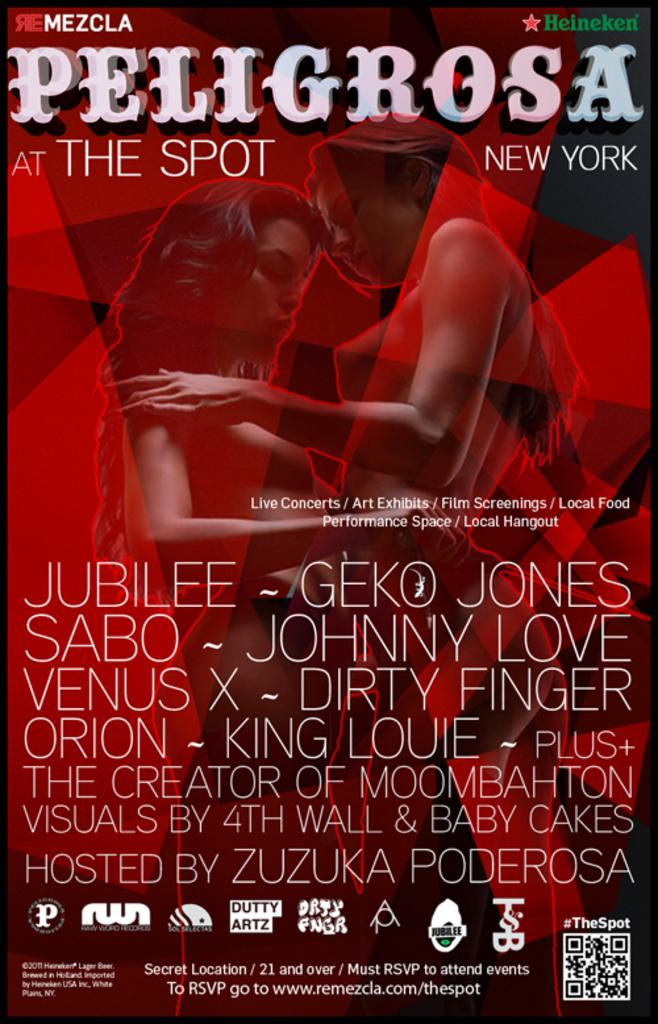Provide a one-sentence caption for the provided image. A red poster for the show Peligrosa The Spot New York. 